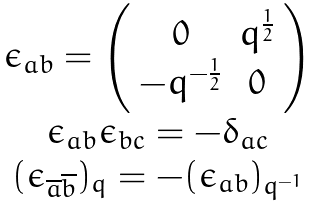<formula> <loc_0><loc_0><loc_500><loc_500>\begin{array} { c } { { \epsilon _ { a b } = \left ( \begin{array} { c c } { 0 } & { { q ^ { \frac { 1 } { 2 } } } } \\ { { - q ^ { - \frac { 1 } { 2 } } } } & { 0 } \end{array} \right ) } } \\ { { \epsilon _ { a b } \epsilon _ { b c } = - \delta _ { a c } } } \\ { { ( \epsilon _ { \overline { a } \overline { b } } ) _ { q } = - ( \epsilon _ { a b } ) _ { q ^ { - 1 } } } } \end{array}</formula> 